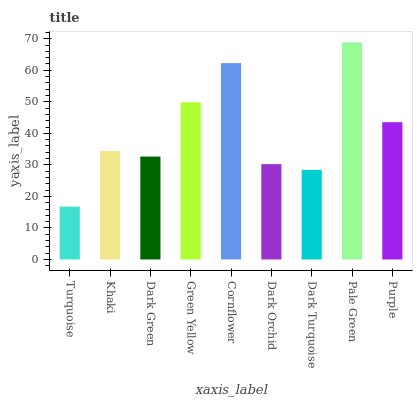Is Turquoise the minimum?
Answer yes or no. Yes. Is Pale Green the maximum?
Answer yes or no. Yes. Is Khaki the minimum?
Answer yes or no. No. Is Khaki the maximum?
Answer yes or no. No. Is Khaki greater than Turquoise?
Answer yes or no. Yes. Is Turquoise less than Khaki?
Answer yes or no. Yes. Is Turquoise greater than Khaki?
Answer yes or no. No. Is Khaki less than Turquoise?
Answer yes or no. No. Is Khaki the high median?
Answer yes or no. Yes. Is Khaki the low median?
Answer yes or no. Yes. Is Dark Turquoise the high median?
Answer yes or no. No. Is Green Yellow the low median?
Answer yes or no. No. 